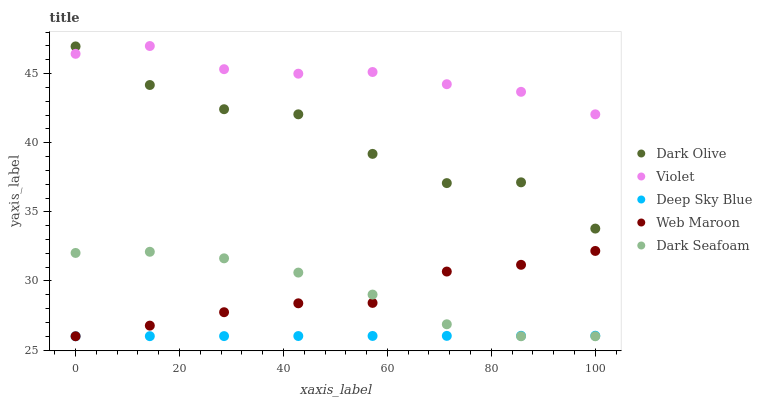Does Deep Sky Blue have the minimum area under the curve?
Answer yes or no. Yes. Does Violet have the maximum area under the curve?
Answer yes or no. Yes. Does Dark Olive have the minimum area under the curve?
Answer yes or no. No. Does Dark Olive have the maximum area under the curve?
Answer yes or no. No. Is Deep Sky Blue the smoothest?
Answer yes or no. Yes. Is Dark Olive the roughest?
Answer yes or no. Yes. Is Web Maroon the smoothest?
Answer yes or no. No. Is Web Maroon the roughest?
Answer yes or no. No. Does Dark Seafoam have the lowest value?
Answer yes or no. Yes. Does Dark Olive have the lowest value?
Answer yes or no. No. Does Violet have the highest value?
Answer yes or no. Yes. Does Dark Olive have the highest value?
Answer yes or no. No. Is Dark Seafoam less than Dark Olive?
Answer yes or no. Yes. Is Violet greater than Dark Seafoam?
Answer yes or no. Yes. Does Dark Olive intersect Violet?
Answer yes or no. Yes. Is Dark Olive less than Violet?
Answer yes or no. No. Is Dark Olive greater than Violet?
Answer yes or no. No. Does Dark Seafoam intersect Dark Olive?
Answer yes or no. No. 